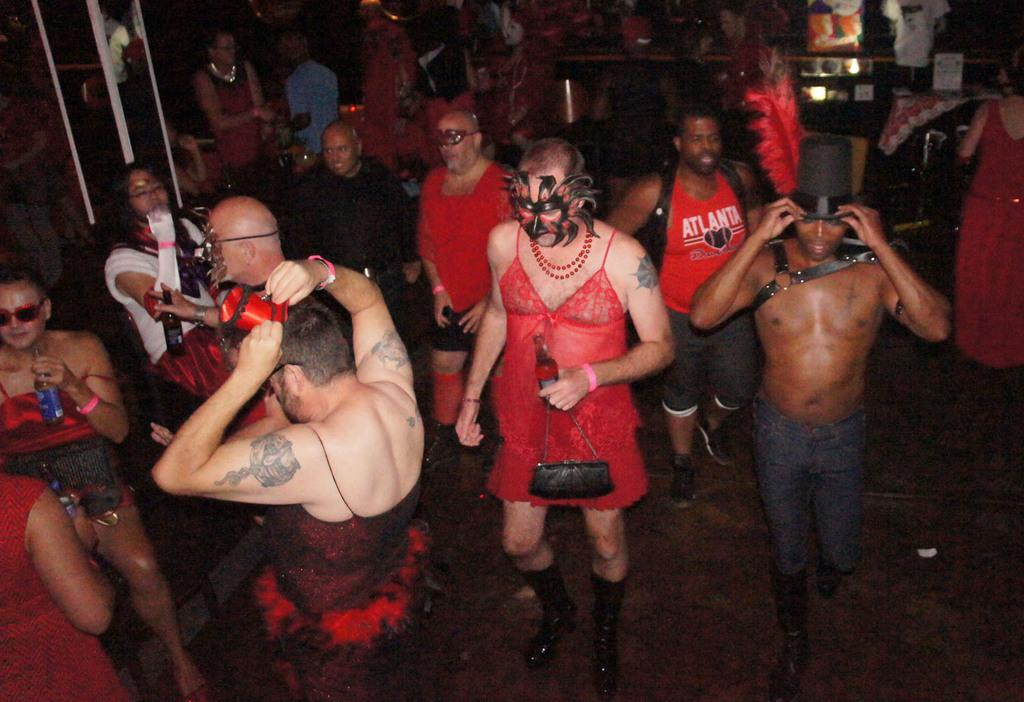Who or what can be seen in the image? There are people in the image. Where are the people located? The people are in one place. What are the people wearing on their faces? The people are wearing masks on their faces. What type of tail can be seen on the people in the image? There are no tails visible on the people in the image. How does the steam affect the people in the image? There is no steam present in the image. 